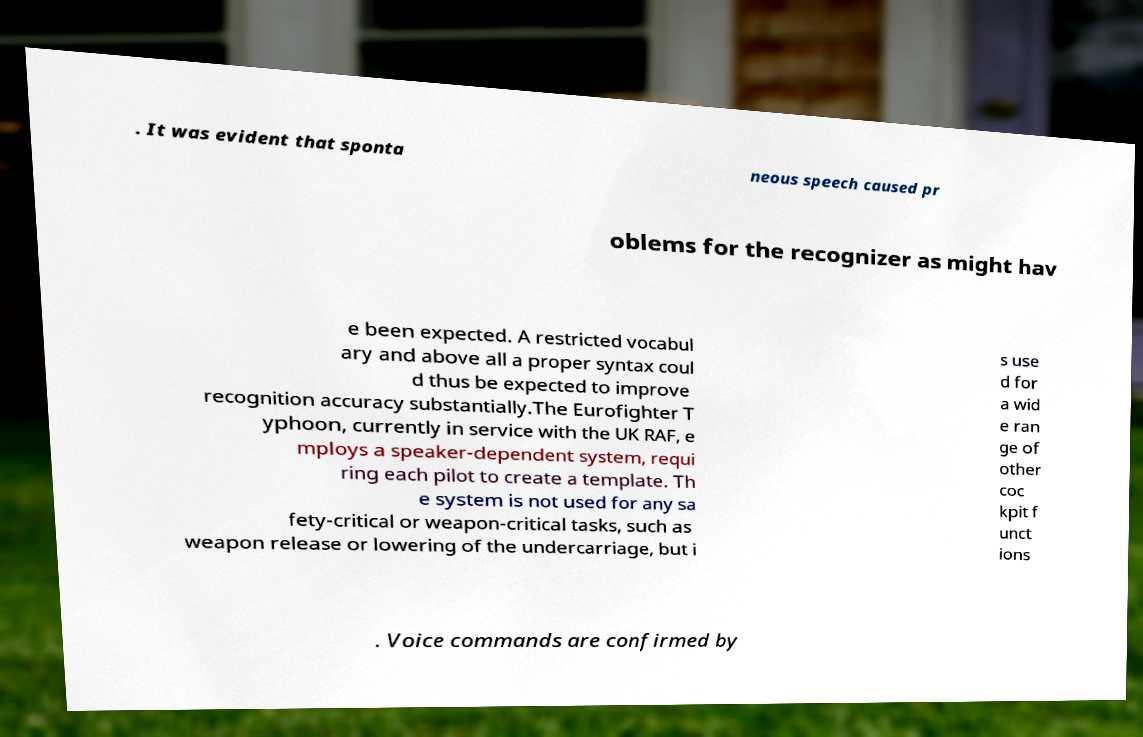What messages or text are displayed in this image? I need them in a readable, typed format. . It was evident that sponta neous speech caused pr oblems for the recognizer as might hav e been expected. A restricted vocabul ary and above all a proper syntax coul d thus be expected to improve recognition accuracy substantially.The Eurofighter T yphoon, currently in service with the UK RAF, e mploys a speaker-dependent system, requi ring each pilot to create a template. Th e system is not used for any sa fety-critical or weapon-critical tasks, such as weapon release or lowering of the undercarriage, but i s use d for a wid e ran ge of other coc kpit f unct ions . Voice commands are confirmed by 